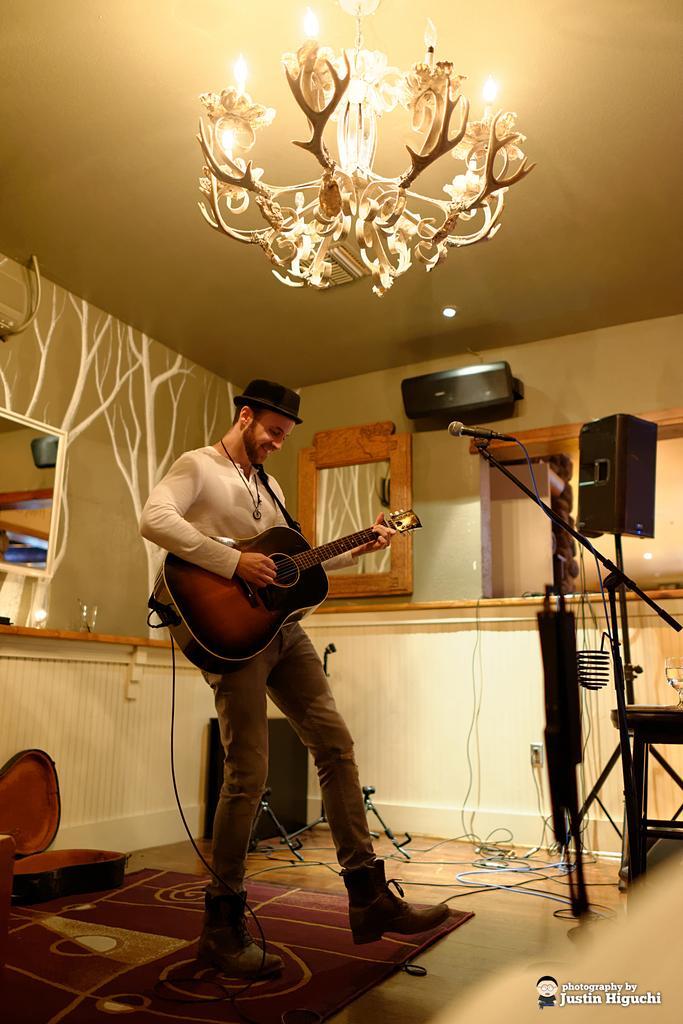Can you describe this image briefly? There is a room. He is standing. His playing a guitar. He's wearing a cap. We can see in background lights,curtain,window. 